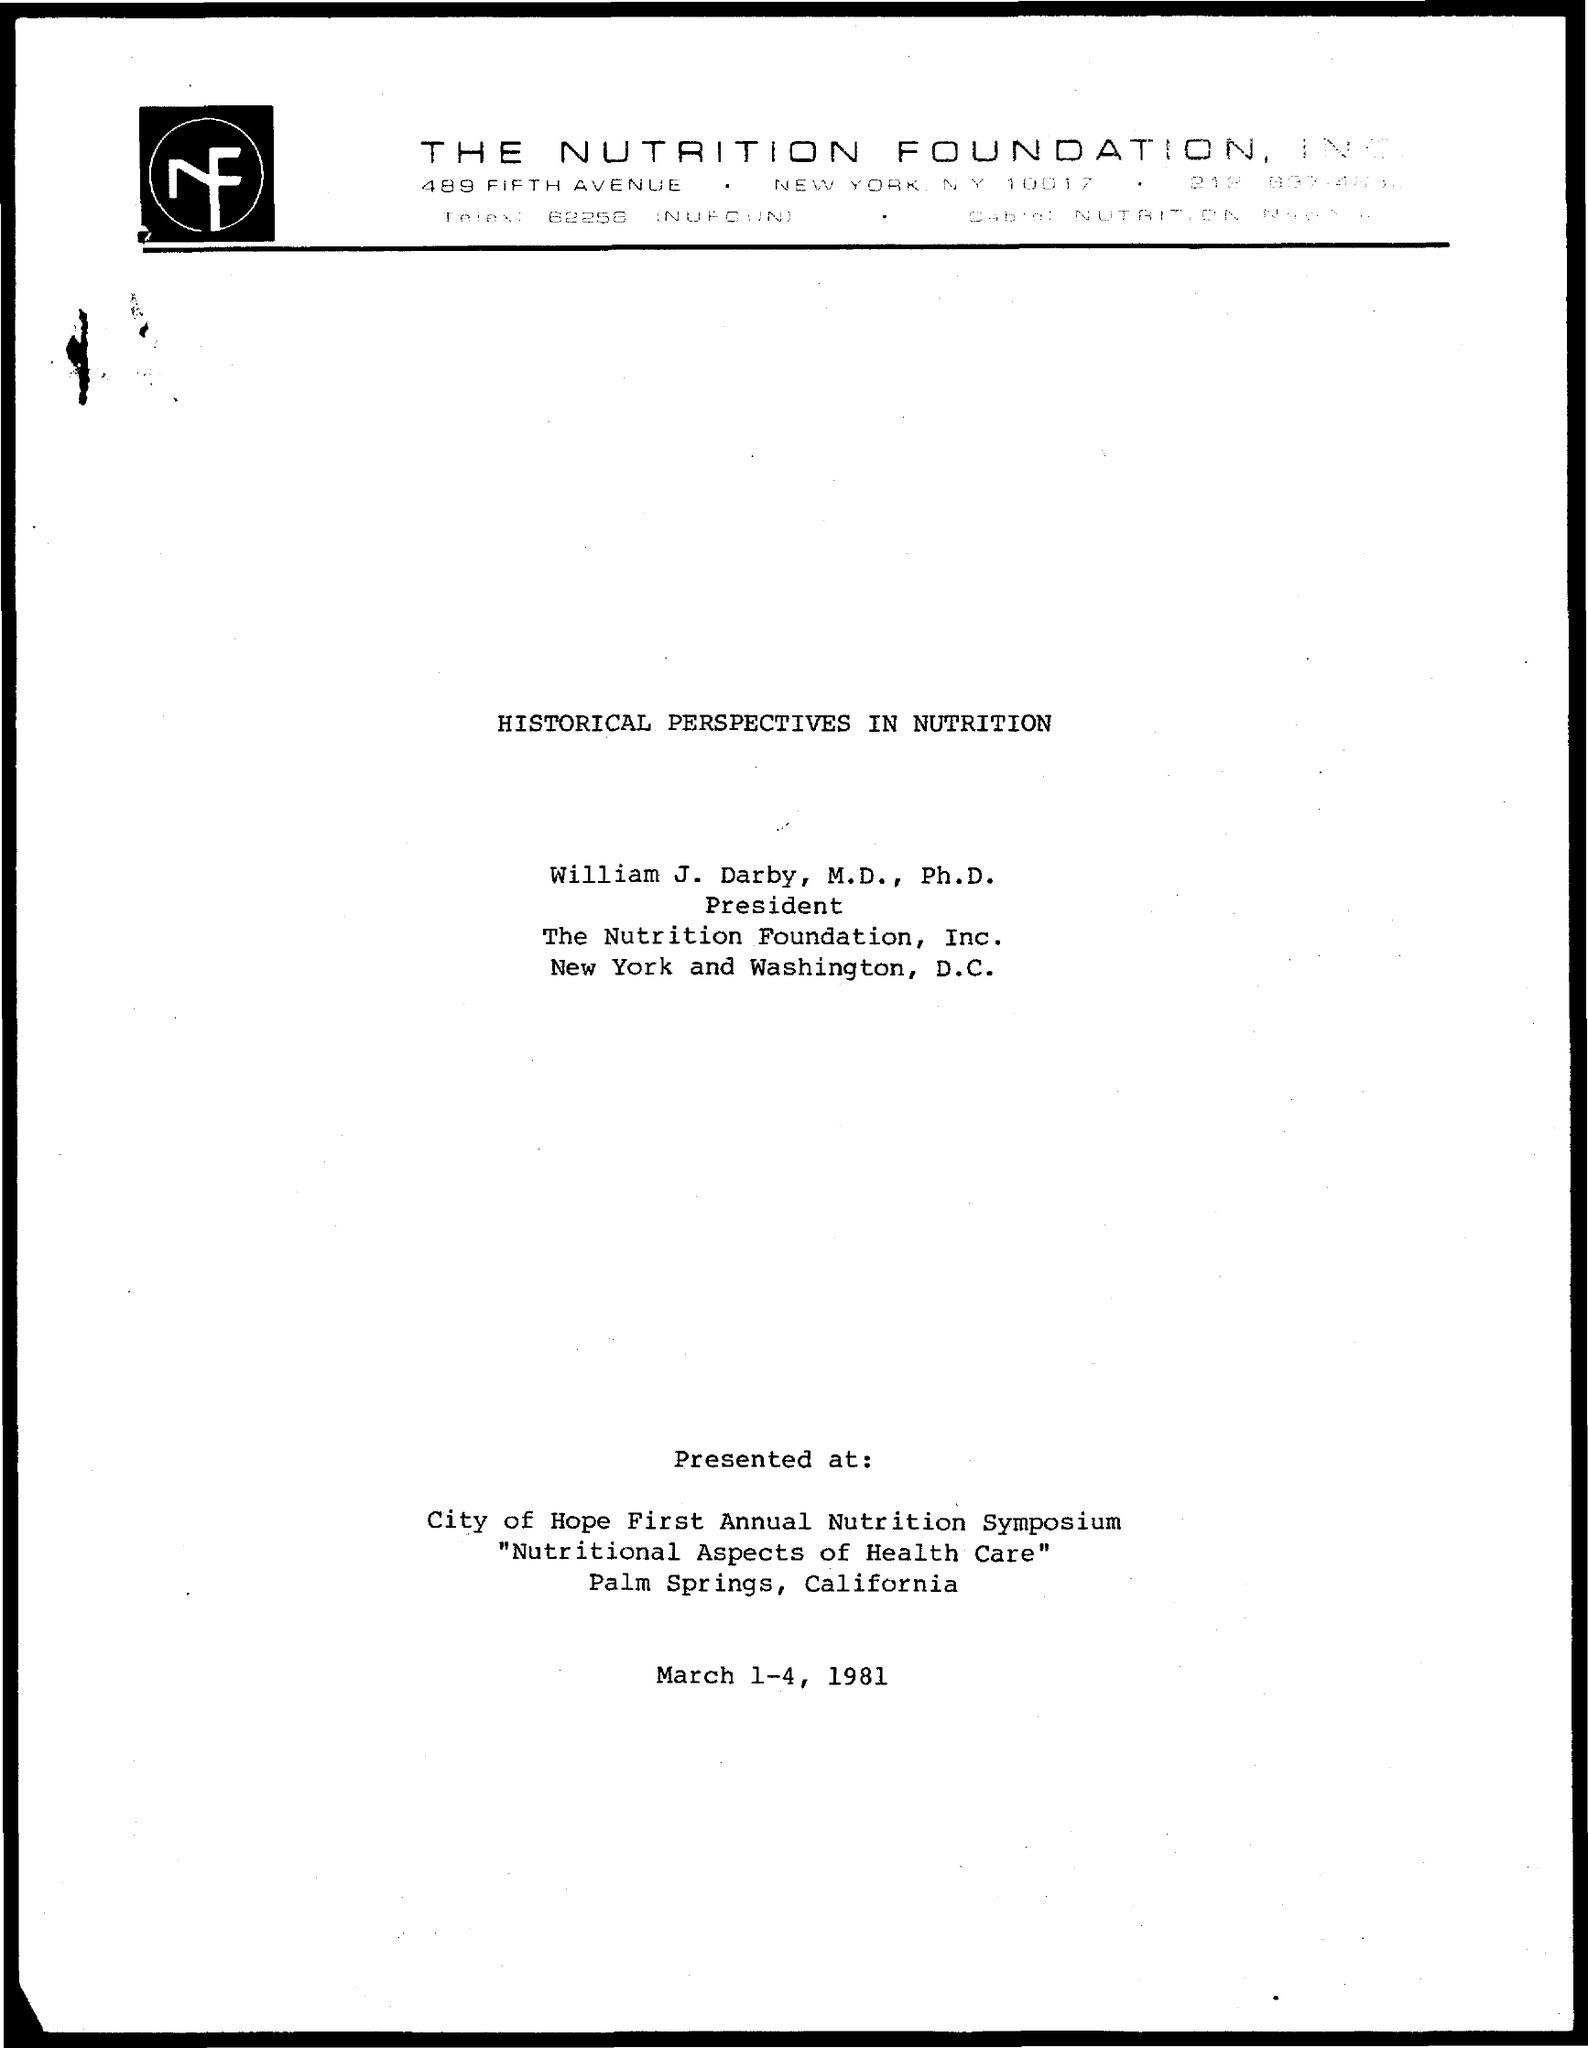List a handful of essential elements in this visual. William J. Darby, M.D., Ph.D., is the current president. The title of the document is "Historical Perspectives in Nutrition. 